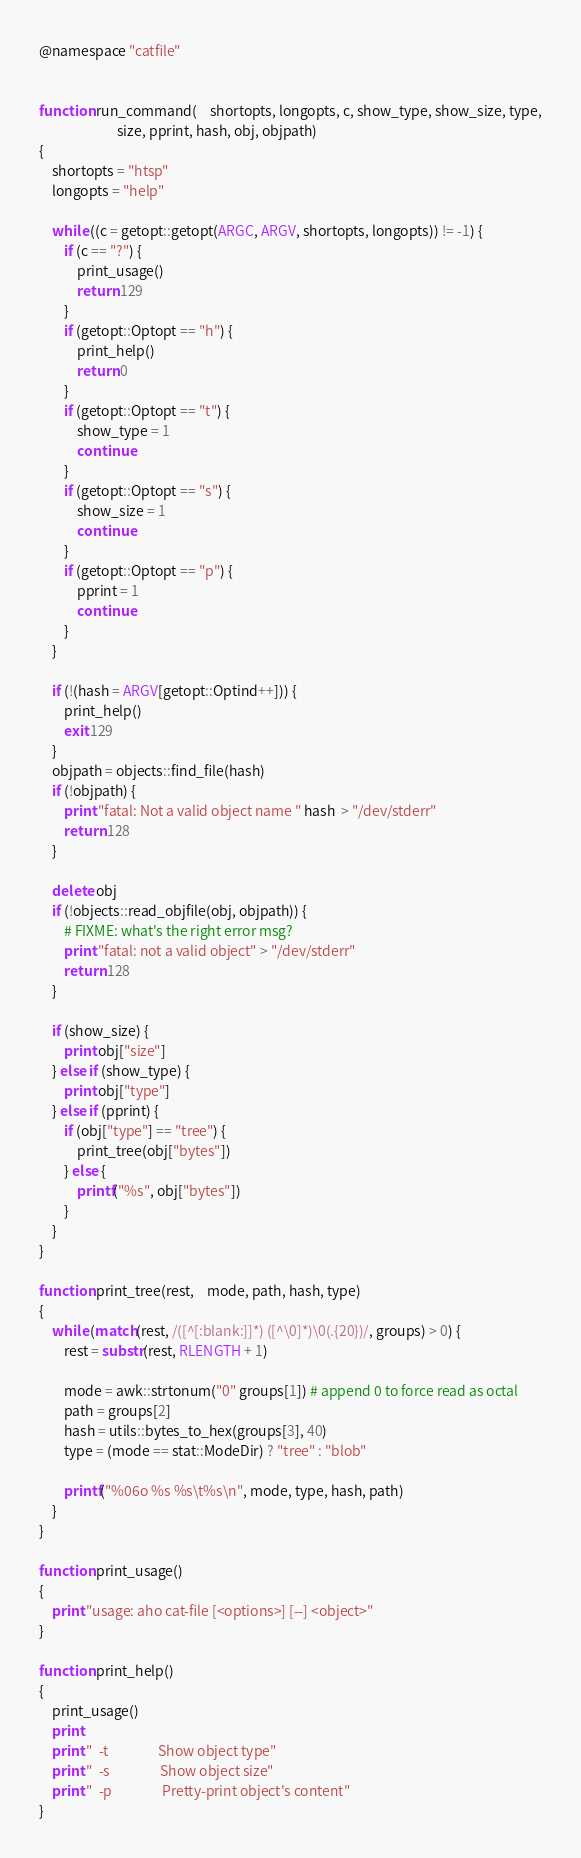<code> <loc_0><loc_0><loc_500><loc_500><_Awk_>@namespace "catfile"


function run_command(    shortopts, longopts, c, show_type, show_size, type,
                         size, pprint, hash, obj, objpath)
{
    shortopts = "htsp"
    longopts = "help"

    while ((c = getopt::getopt(ARGC, ARGV, shortopts, longopts)) != -1) {
        if (c == "?") {
            print_usage()
            return 129
        }
        if (getopt::Optopt == "h") {
            print_help()
            return 0
        }
        if (getopt::Optopt == "t") {
            show_type = 1
            continue
        }
        if (getopt::Optopt == "s") {
            show_size = 1
            continue
        }
        if (getopt::Optopt == "p") {
            pprint = 1
            continue
        }
    }

    if (!(hash = ARGV[getopt::Optind++])) {
        print_help()
        exit 129
    }
    objpath = objects::find_file(hash)
    if (!objpath) {
        print "fatal: Not a valid object name " hash  > "/dev/stderr"
        return 128
    }

    delete obj
    if (!objects::read_objfile(obj, objpath)) {
        # FIXME: what's the right error msg?
        print "fatal: not a valid object" > "/dev/stderr"
        return 128
    }

    if (show_size) {
        print obj["size"]
    } else if (show_type) {
        print obj["type"]
    } else if (pprint) {
        if (obj["type"] == "tree") {
            print_tree(obj["bytes"])
        } else {
            printf("%s", obj["bytes"])
        }
    }
}

function print_tree(rest,    mode, path, hash, type)
{
    while (match(rest, /([^[:blank:]]*) ([^\0]*)\0(.{20})/, groups) > 0) {
        rest = substr(rest, RLENGTH + 1)

        mode = awk::strtonum("0" groups[1]) # append 0 to force read as octal
        path = groups[2]
        hash = utils::bytes_to_hex(groups[3], 40)
        type = (mode == stat::ModeDir) ? "tree" : "blob"

        printf("%06o %s %s\t%s\n", mode, type, hash, path)
    }
}

function print_usage()
{
    print "usage: aho cat-file [<options>] [--] <object>"
}

function print_help()
{
    print_usage()
    print
    print "  -t                Show object type"
    print "  -s                Show object size"
    print "  -p                Pretty-print object's content"
}
</code> 